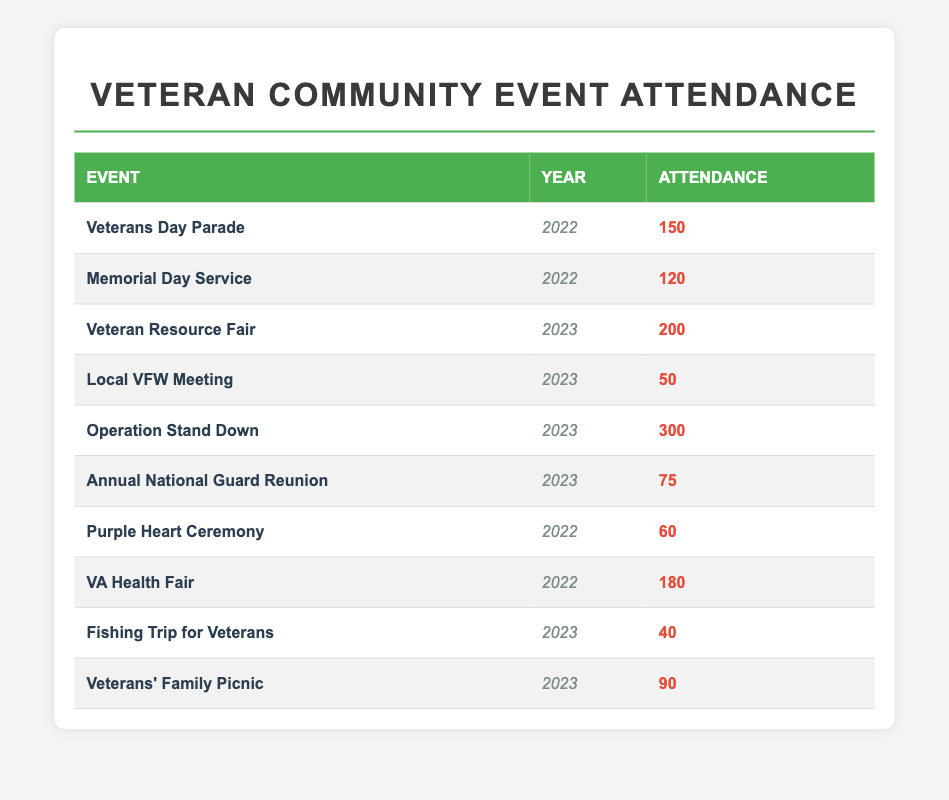What was the total attendance for events in 2022? To find the total attendance for 2022, we need to sum the attendance values for all events in that year. The events for 2022 are: Veterans Day Parade (150), Memorial Day Service (120), Purple Heart Ceremony (60), and VA Health Fair (180). Adding these together: 150 + 120 + 60 + 180 = 510.
Answer: 510 Which event had the highest attendance in 2023? To determine which event had the highest attendance in 2023, we need to look at the attendance figures for that year. The events in 2023 are: Veteran Resource Fair (200), Local VFW Meeting (50), Operation Stand Down (300), Annual National Guard Reunion (75), Fishing Trip for Veterans (40), and Veterans' Family Picnic (90). Comparing these figures, Operation Stand Down has the highest attendance at 300.
Answer: 300 Is the attendance for the VA Health Fair greater than the attendance for the Fishing Trip for Veterans? The attendance for the VA Health Fair in 2022 is 180, while the attendance for the Fishing Trip for Veterans in 2023 is 40. Since 180 is greater than 40, the statement is true.
Answer: Yes What is the average attendance for events in 2023? To find the average attendance for events in 2023, we first identify the events: Veteran Resource Fair (200), Local VFW Meeting (50), Operation Stand Down (300), Annual National Guard Reunion (75), Fishing Trip for Veterans (40), and Veterans' Family Picnic (90). We sum those attendances: 200 + 50 + 300 + 75 + 40 + 90 = 755. There are 6 events, so the average is 755 / 6 ≈ 125.83.
Answer: 125.83 Did attendance for the Memorial Day Service exceed 100 in 2022? The attendance for the Memorial Day Service in 2022 is 120. Since 120 is greater than 100, the answer is yes.
Answer: Yes What is the difference in attendance between the VA Health Fair and the Veterans Day Parade? The attendance for the VA Health Fair is 180 and for the Veterans Day Parade it is 150. To find the difference, we subtract: 180 - 150 = 30.
Answer: 30 Which year had more total attendance, 2022 or 2023? First, we calculate total attendance for both years. For 2022: Veterans Day Parade (150) + Memorial Day Service (120) + Purple Heart Ceremony (60) + VA Health Fair (180) = 510. For 2023: Veteran Resource Fair (200) + Local VFW Meeting (50) + Operation Stand Down (300) + Annual National Guard Reunion (75) + Fishing Trip for Veterans (40) + Veterans' Family Picnic (90) = 755. Since 755 (2023) is greater than 510 (2022), 2023 had more total attendance.
Answer: 2023 How many events had attendance numbers below 100 in 2023? Looking at the attendance figures for 2023: Local VFW Meeting (50), Fishing Trip for Veterans (40), and Veterans' Family Picnic (90). Three events have attendance below 100.
Answer: 3 